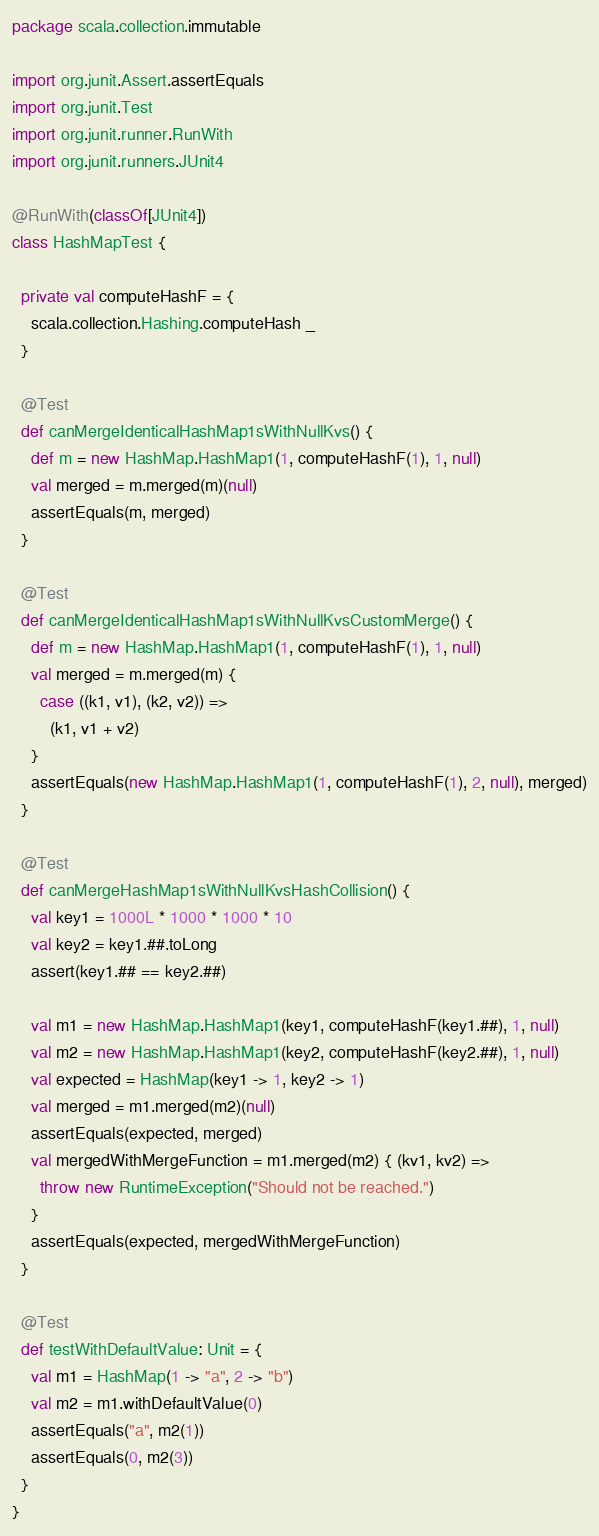<code> <loc_0><loc_0><loc_500><loc_500><_Scala_>package scala.collection.immutable

import org.junit.Assert.assertEquals
import org.junit.Test
import org.junit.runner.RunWith
import org.junit.runners.JUnit4

@RunWith(classOf[JUnit4])
class HashMapTest {

  private val computeHashF = {
    scala.collection.Hashing.computeHash _
  }

  @Test
  def canMergeIdenticalHashMap1sWithNullKvs() {
    def m = new HashMap.HashMap1(1, computeHashF(1), 1, null)
    val merged = m.merged(m)(null)
    assertEquals(m, merged)
  }

  @Test
  def canMergeIdenticalHashMap1sWithNullKvsCustomMerge() {
    def m = new HashMap.HashMap1(1, computeHashF(1), 1, null)
    val merged = m.merged(m) {
      case ((k1, v1), (k2, v2)) =>
        (k1, v1 + v2)
    }
    assertEquals(new HashMap.HashMap1(1, computeHashF(1), 2, null), merged)
  }

  @Test
  def canMergeHashMap1sWithNullKvsHashCollision() {
    val key1 = 1000L * 1000 * 1000 * 10
    val key2 = key1.##.toLong
    assert(key1.## == key2.##)

    val m1 = new HashMap.HashMap1(key1, computeHashF(key1.##), 1, null)
    val m2 = new HashMap.HashMap1(key2, computeHashF(key2.##), 1, null)
    val expected = HashMap(key1 -> 1, key2 -> 1)
    val merged = m1.merged(m2)(null)
    assertEquals(expected, merged)
    val mergedWithMergeFunction = m1.merged(m2) { (kv1, kv2) =>
      throw new RuntimeException("Should not be reached.")
    }
    assertEquals(expected, mergedWithMergeFunction)
  }

  @Test
  def testWithDefaultValue: Unit = {
    val m1 = HashMap(1 -> "a", 2 -> "b")
    val m2 = m1.withDefaultValue(0)
    assertEquals("a", m2(1))
    assertEquals(0, m2(3))
  }
}
</code> 